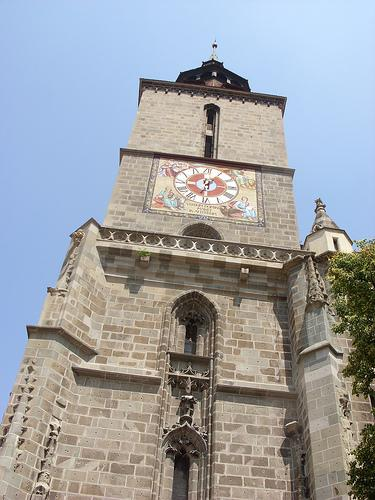Question: what is it?
Choices:
A. A bug.
B. A car.
C. A person.
D. Building.
Answer with the letter. Answer: D 